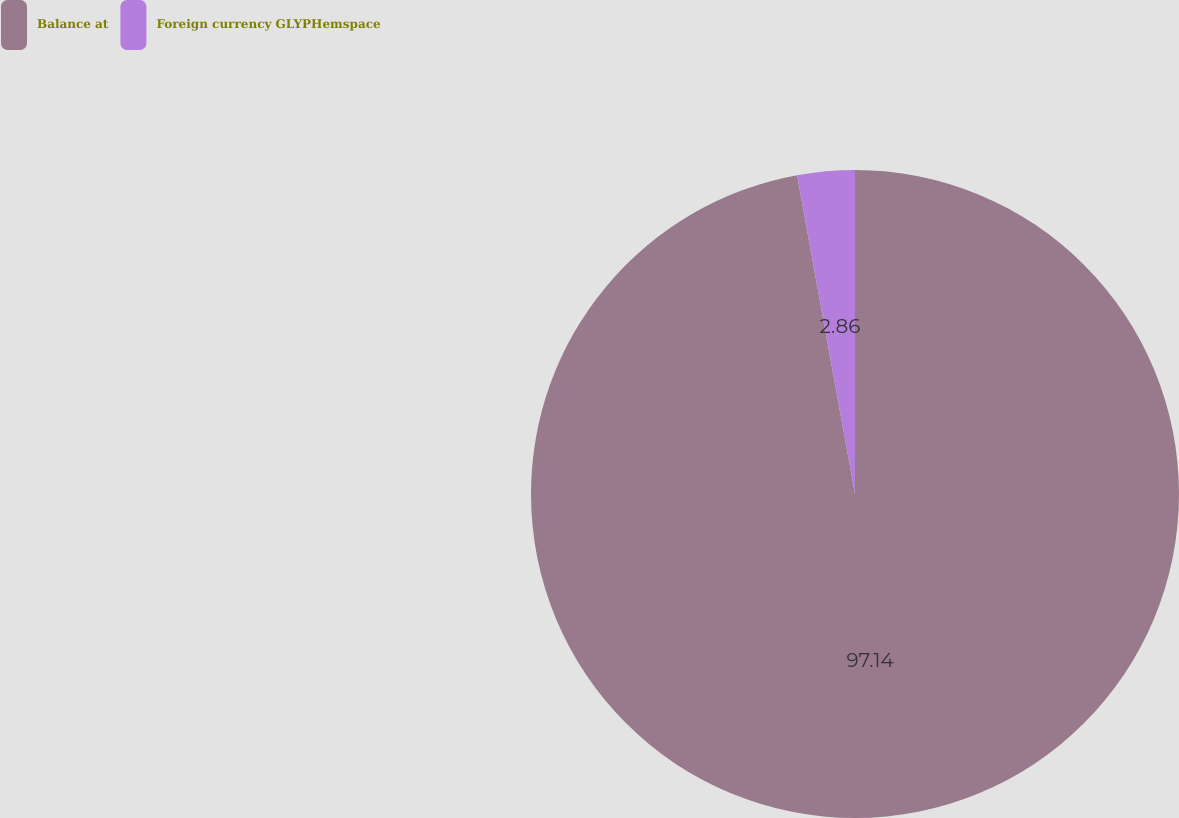Convert chart. <chart><loc_0><loc_0><loc_500><loc_500><pie_chart><fcel>Balance at<fcel>Foreign currency GLYPHemspace<nl><fcel>97.14%<fcel>2.86%<nl></chart> 